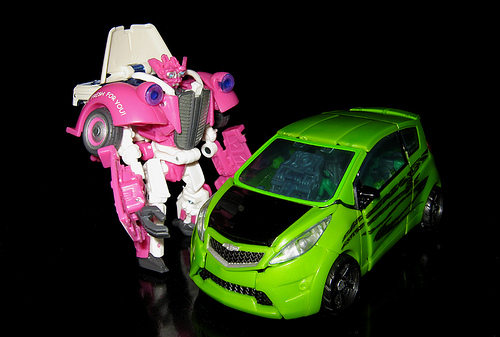<image>
Is the transformer next to the car? Yes. The transformer is positioned adjacent to the car, located nearby in the same general area. 